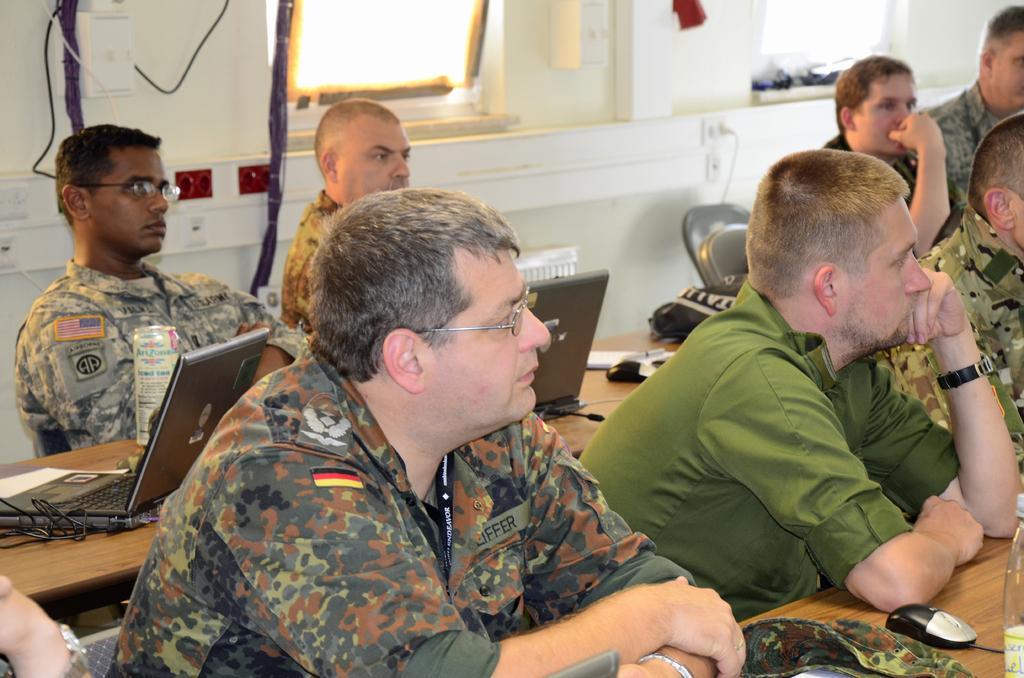Describe this image in one or two sentences. In this picture we can see some people are sitting in front of tables, there are laptops, a mouse, a book and a wire present on this table, in the background we can see socket board and a window, at the right bottom there is a mouse, a bottle and a cloth. 